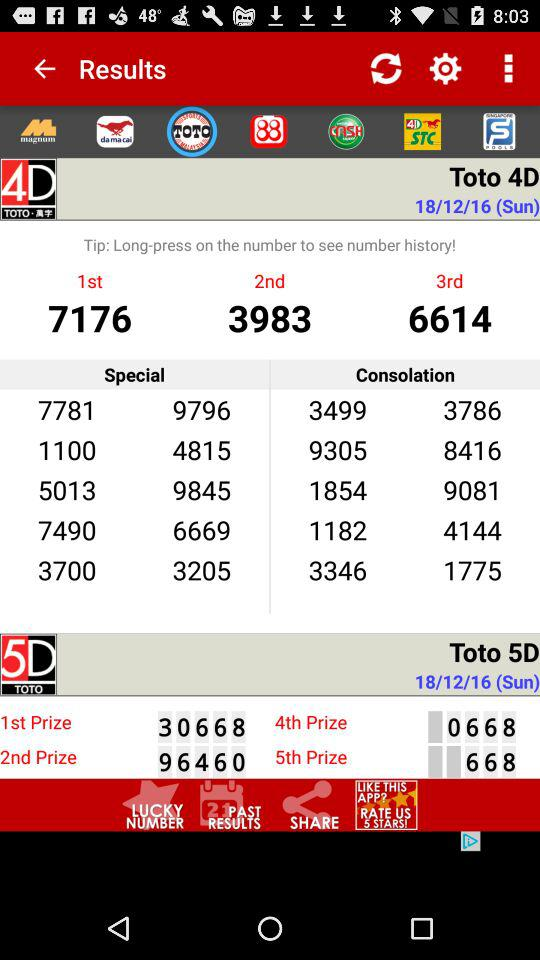What is the tip? The tip is to long-press on the number to see the number history. 